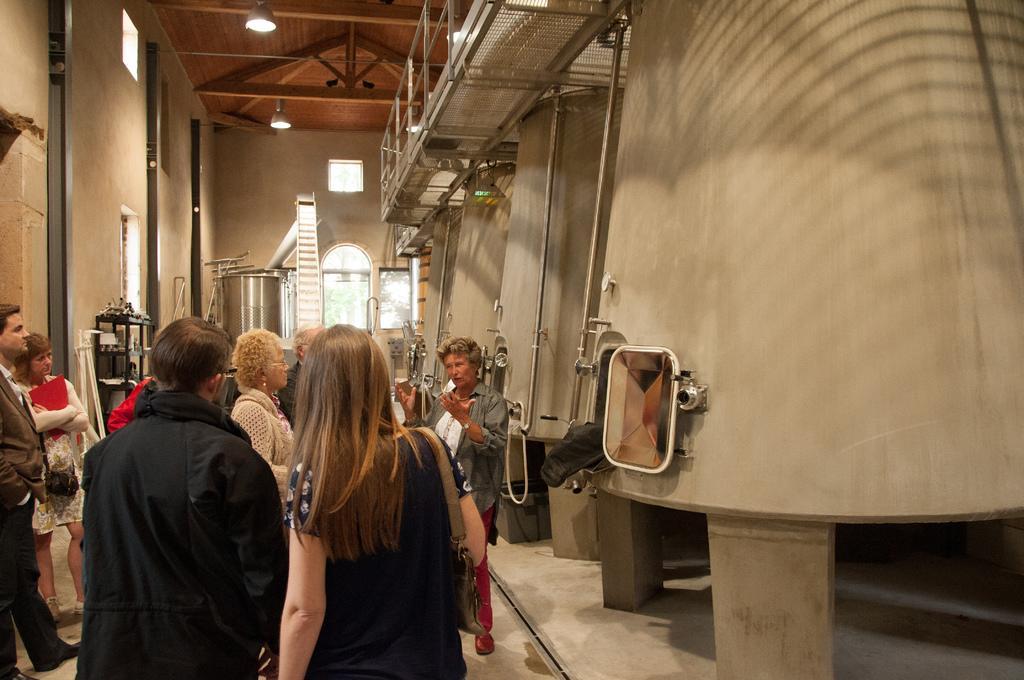Could you give a brief overview of what you see in this image? In this image there are people standing, on the right side there are tanks, in the background there is a wall, ladder and a tank, at the top there is a wooden roof and lights. 